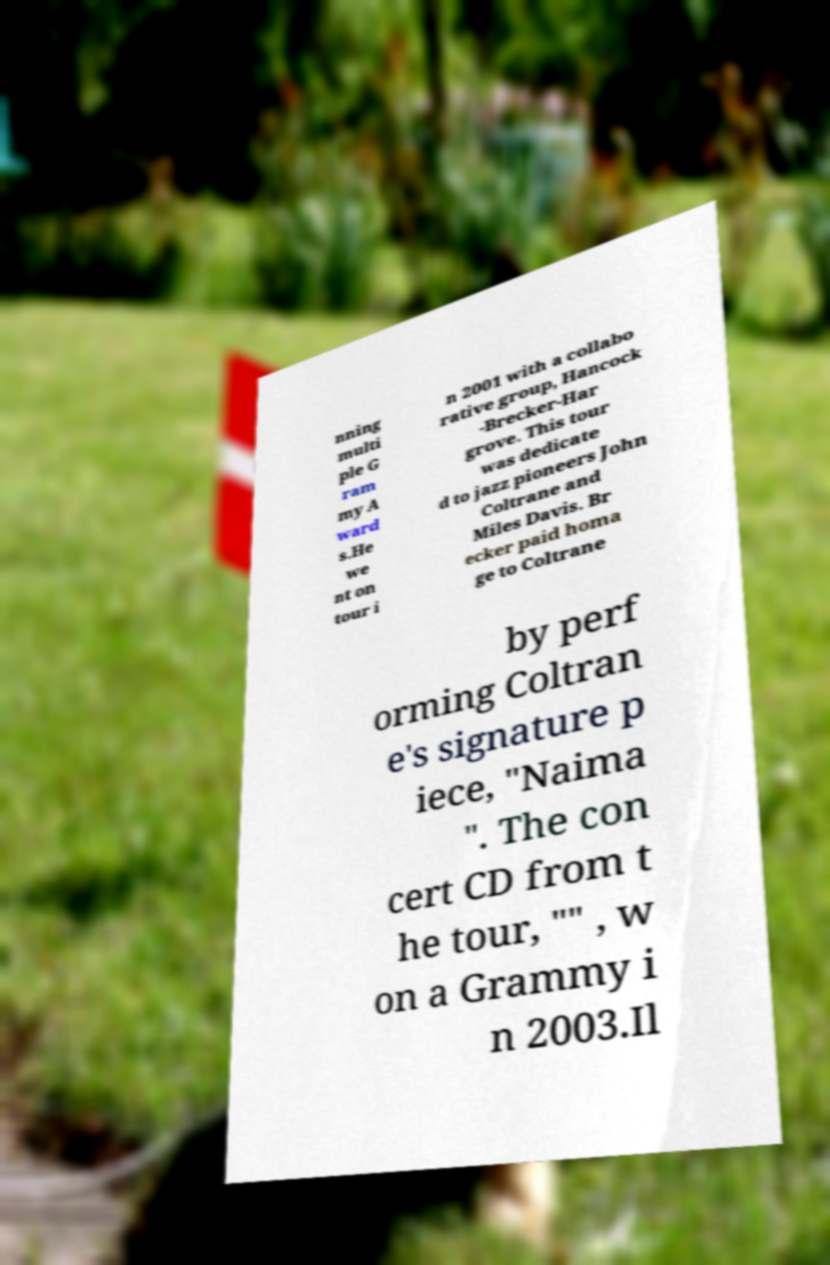Please read and relay the text visible in this image. What does it say? nning multi ple G ram my A ward s.He we nt on tour i n 2001 with a collabo rative group, Hancock -Brecker-Har grove. This tour was dedicate d to jazz pioneers John Coltrane and Miles Davis. Br ecker paid homa ge to Coltrane by perf orming Coltran e's signature p iece, "Naima ". The con cert CD from t he tour, "" , w on a Grammy i n 2003.Il 